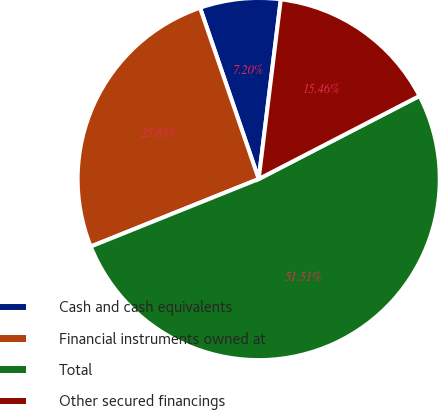Convert chart. <chart><loc_0><loc_0><loc_500><loc_500><pie_chart><fcel>Cash and cash equivalents<fcel>Financial instruments owned at<fcel>Total<fcel>Other secured financings<nl><fcel>7.2%<fcel>25.83%<fcel>51.51%<fcel>15.46%<nl></chart> 